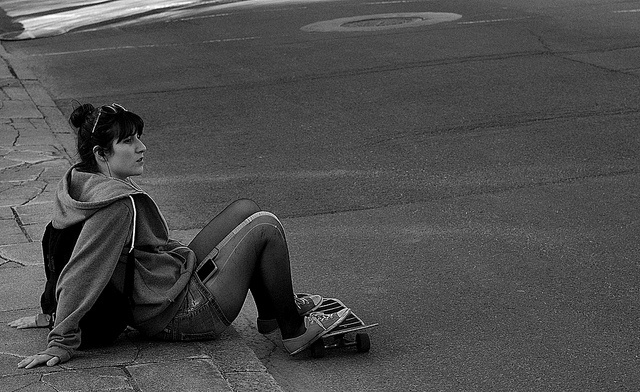Describe the objects in this image and their specific colors. I can see people in gray, black, and lightgray tones, backpack in gray, black, white, and darkgray tones, skateboard in gray, black, darkgray, and lightgray tones, and cell phone in gray and black tones in this image. 